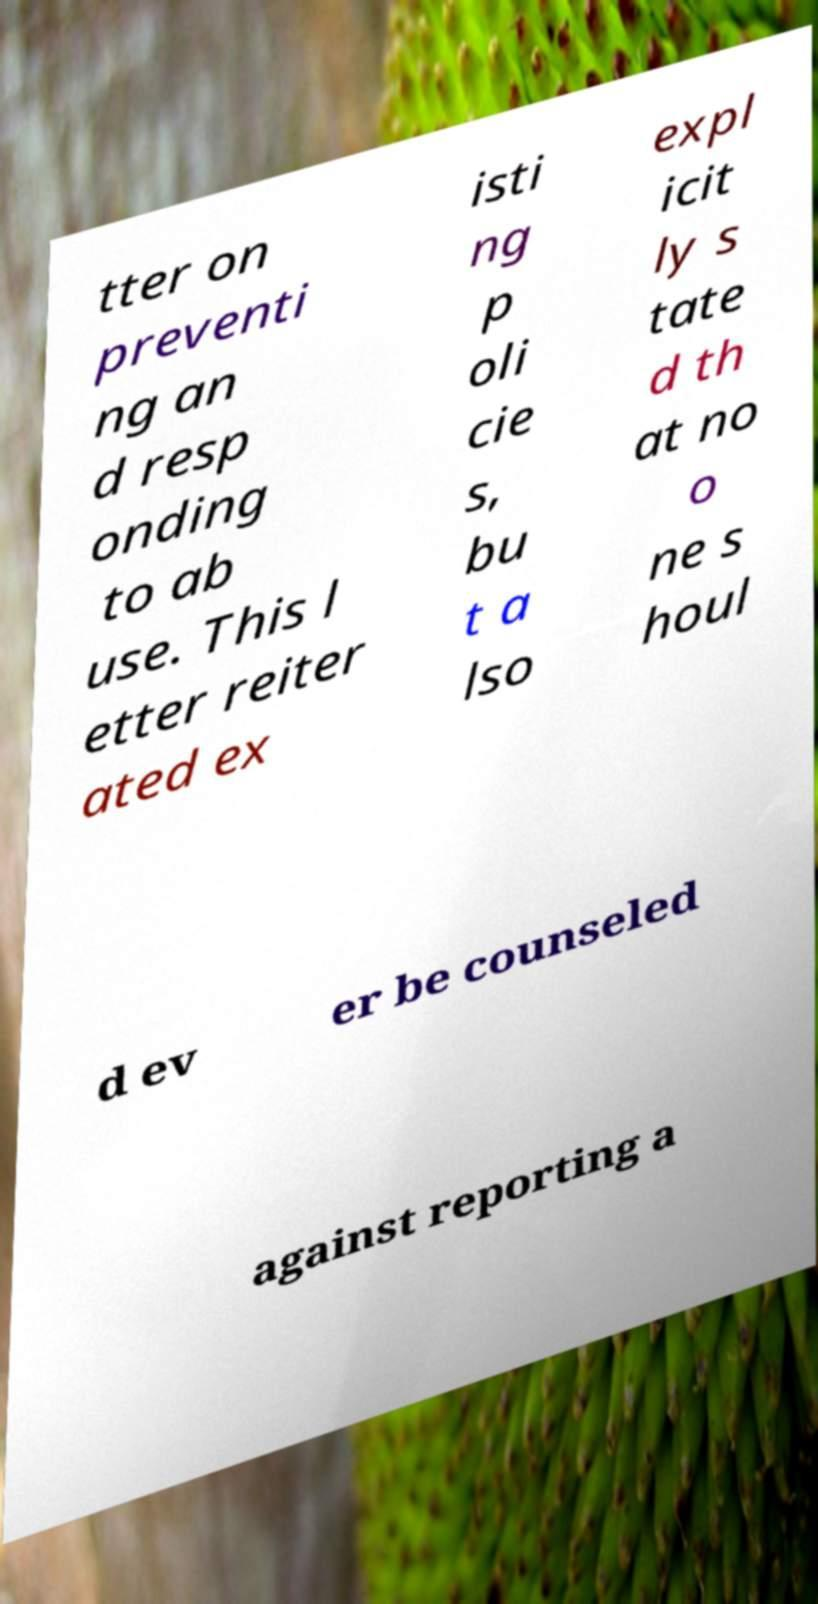Can you read and provide the text displayed in the image?This photo seems to have some interesting text. Can you extract and type it out for me? tter on preventi ng an d resp onding to ab use. This l etter reiter ated ex isti ng p oli cie s, bu t a lso expl icit ly s tate d th at no o ne s houl d ev er be counseled against reporting a 